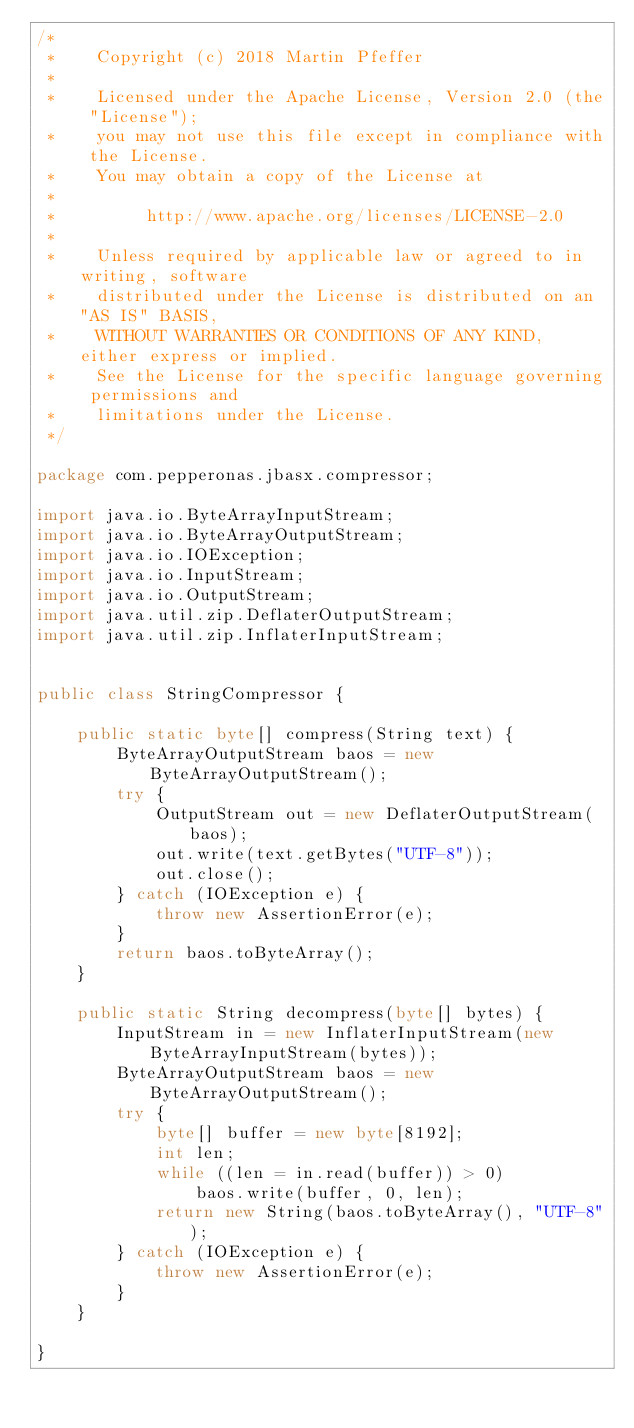<code> <loc_0><loc_0><loc_500><loc_500><_Java_>/*
 *    Copyright (c) 2018 Martin Pfeffer
 *
 *    Licensed under the Apache License, Version 2.0 (the "License");
 *    you may not use this file except in compliance with the License.
 *    You may obtain a copy of the License at
 *
 *         http://www.apache.org/licenses/LICENSE-2.0
 *
 *    Unless required by applicable law or agreed to in writing, software
 *    distributed under the License is distributed on an "AS IS" BASIS,
 *    WITHOUT WARRANTIES OR CONDITIONS OF ANY KIND, either express or implied.
 *    See the License for the specific language governing permissions and
 *    limitations under the License.
 */

package com.pepperonas.jbasx.compressor;

import java.io.ByteArrayInputStream;
import java.io.ByteArrayOutputStream;
import java.io.IOException;
import java.io.InputStream;
import java.io.OutputStream;
import java.util.zip.DeflaterOutputStream;
import java.util.zip.InflaterInputStream;


public class StringCompressor {

    public static byte[] compress(String text) {
        ByteArrayOutputStream baos = new ByteArrayOutputStream();
        try {
            OutputStream out = new DeflaterOutputStream(baos);
            out.write(text.getBytes("UTF-8"));
            out.close();
        } catch (IOException e) {
            throw new AssertionError(e);
        }
        return baos.toByteArray();
    }

    public static String decompress(byte[] bytes) {
        InputStream in = new InflaterInputStream(new ByteArrayInputStream(bytes));
        ByteArrayOutputStream baos = new ByteArrayOutputStream();
        try {
            byte[] buffer = new byte[8192];
            int len;
            while ((len = in.read(buffer)) > 0)
                baos.write(buffer, 0, len);
            return new String(baos.toByteArray(), "UTF-8");
        } catch (IOException e) {
            throw new AssertionError(e);
        }
    }

}
</code> 